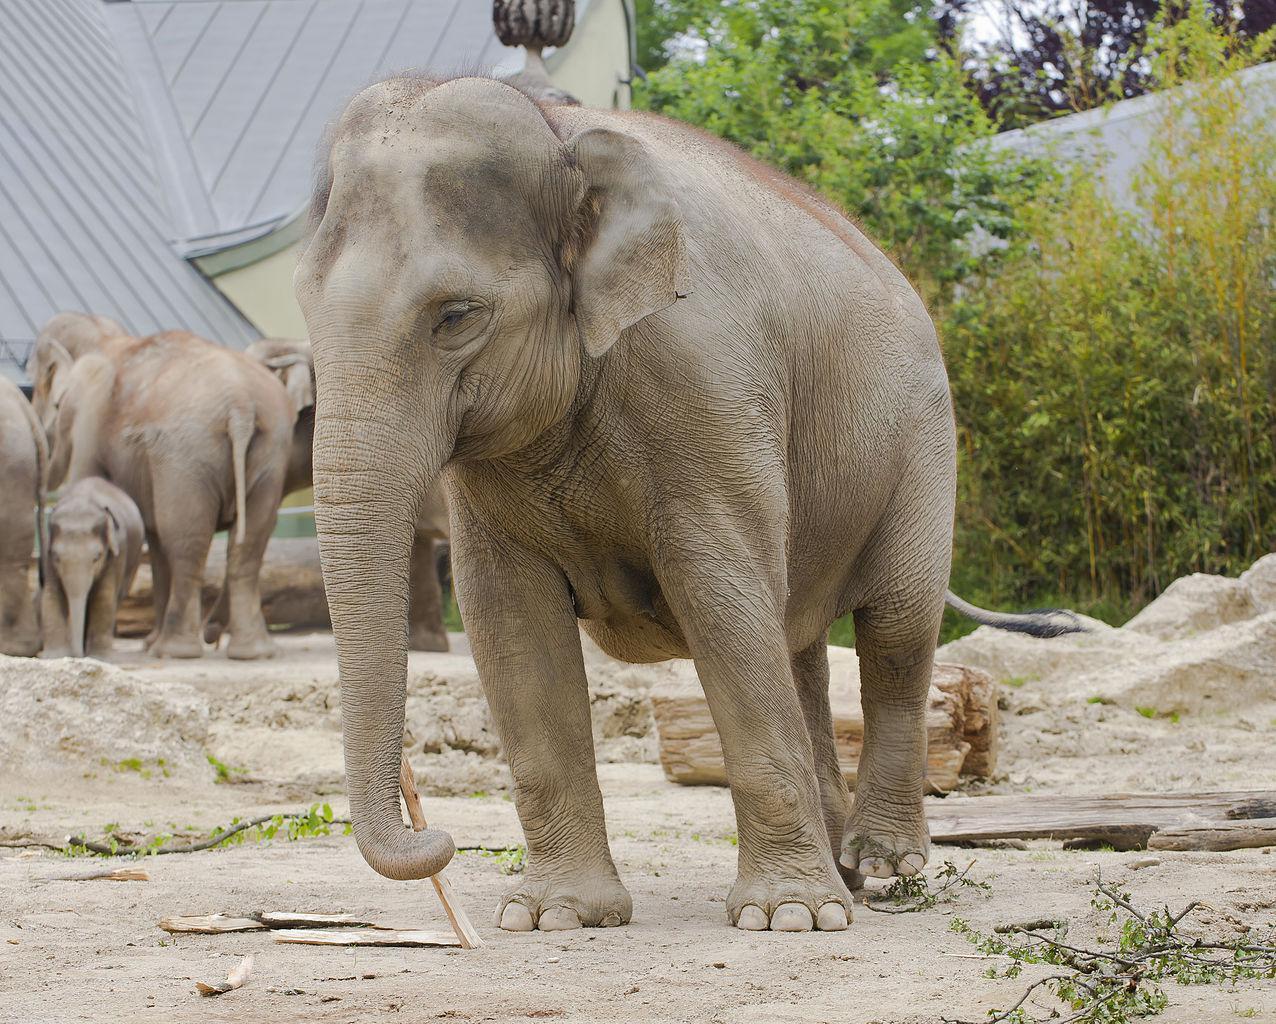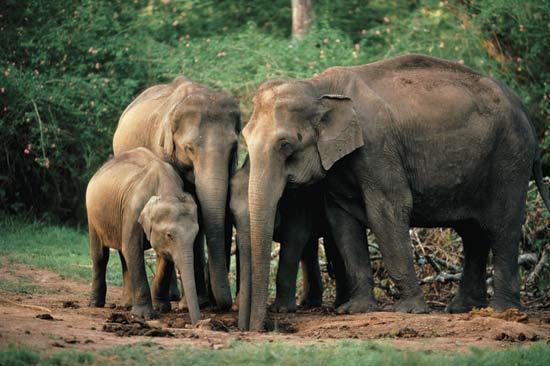The first image is the image on the left, the second image is the image on the right. Given the left and right images, does the statement "There is exactly one elephant facing left and exactly one elephant facing right." hold true? Answer yes or no. No. 